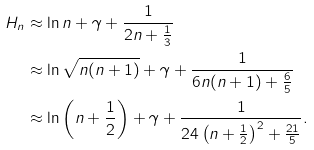<formula> <loc_0><loc_0><loc_500><loc_500>H _ { n } & \approx \ln n + \gamma + \frac { 1 } { 2 n + \frac { 1 } { 3 } } \\ & \approx \ln \sqrt { n ( n + 1 ) } + \gamma + \frac { 1 } { 6 n ( n + 1 ) + \frac { 6 } { 5 } } \\ & \approx \ln \left ( n + \frac { 1 } { 2 } \right ) + \gamma + \frac { 1 } { 2 4 \left ( n + \frac { 1 } { 2 } \right ) ^ { 2 } + \frac { 2 1 } { 5 } } .</formula> 